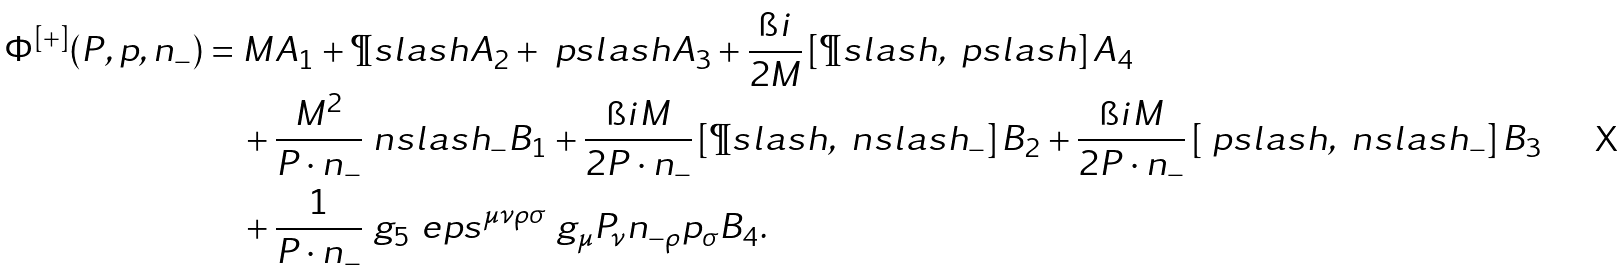Convert formula to latex. <formula><loc_0><loc_0><loc_500><loc_500>\Phi ^ { [ + ] } ( P , p , n _ { - } ) & = M A _ { 1 } + \P s l a s h A _ { 2 } + \ p s l a s h A _ { 3 } + \frac { \i i } { 2 M } \left [ \P s l a s h , \ p s l a s h \right ] A _ { 4 } \\ & \quad + \frac { M ^ { 2 } } { P \cdot n _ { - } } \ n s l a s h _ { - } B _ { 1 } + \frac { \i i M } { 2 P \cdot n _ { - } } \left [ \P s l a s h , \ n s l a s h _ { - } \right ] B _ { 2 } + \frac { \i i M } { 2 P \cdot n _ { - } } \left [ \ p s l a s h , \ n s l a s h _ { - } \right ] B _ { 3 } \\ & \quad + \frac { 1 } { P \cdot n _ { - } } \ g _ { 5 } \ e p s ^ { \mu \nu \rho \sigma } \ g _ { \mu } P _ { \nu } n _ { - \rho } p _ { \sigma } B _ { 4 } .</formula> 